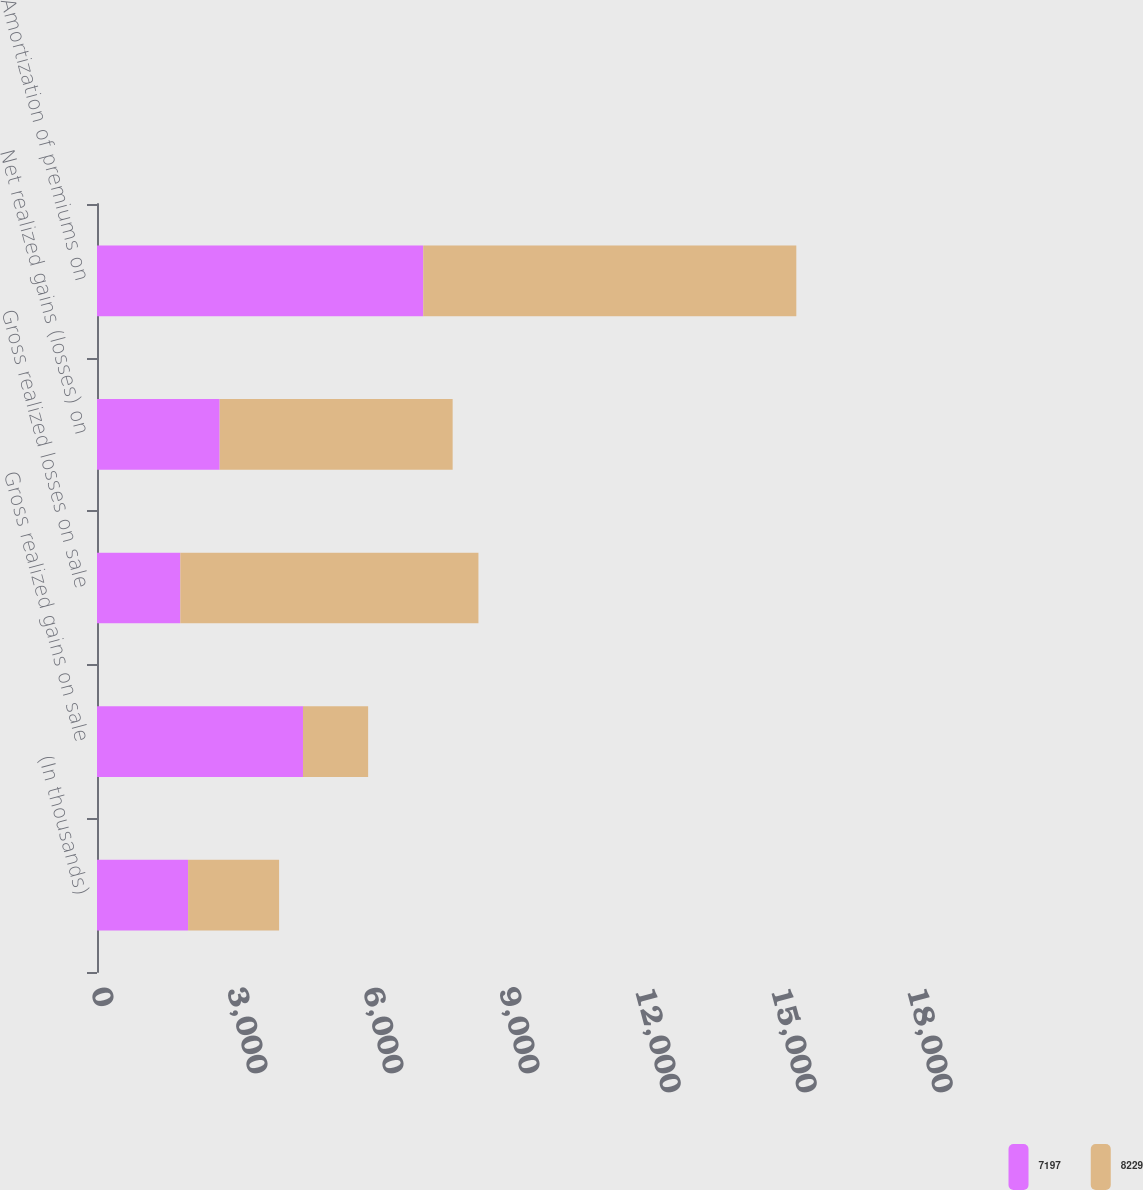Convert chart. <chart><loc_0><loc_0><loc_500><loc_500><stacked_bar_chart><ecel><fcel>(In thousands)<fcel>Gross realized gains on sale<fcel>Gross realized losses on sale<fcel>Net realized gains (losses) on<fcel>Amortization of premiums on<nl><fcel>7197<fcel>2009<fcel>4544<fcel>1838<fcel>2706<fcel>7197<nl><fcel>8229<fcel>2008<fcel>1437<fcel>6576<fcel>5139<fcel>8229<nl></chart> 